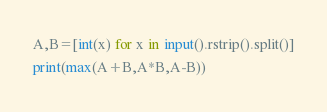Convert code to text. <code><loc_0><loc_0><loc_500><loc_500><_Python_>A,B=[int(x) for x in input().rstrip().split()]
print(max(A+B,A*B,A-B))</code> 